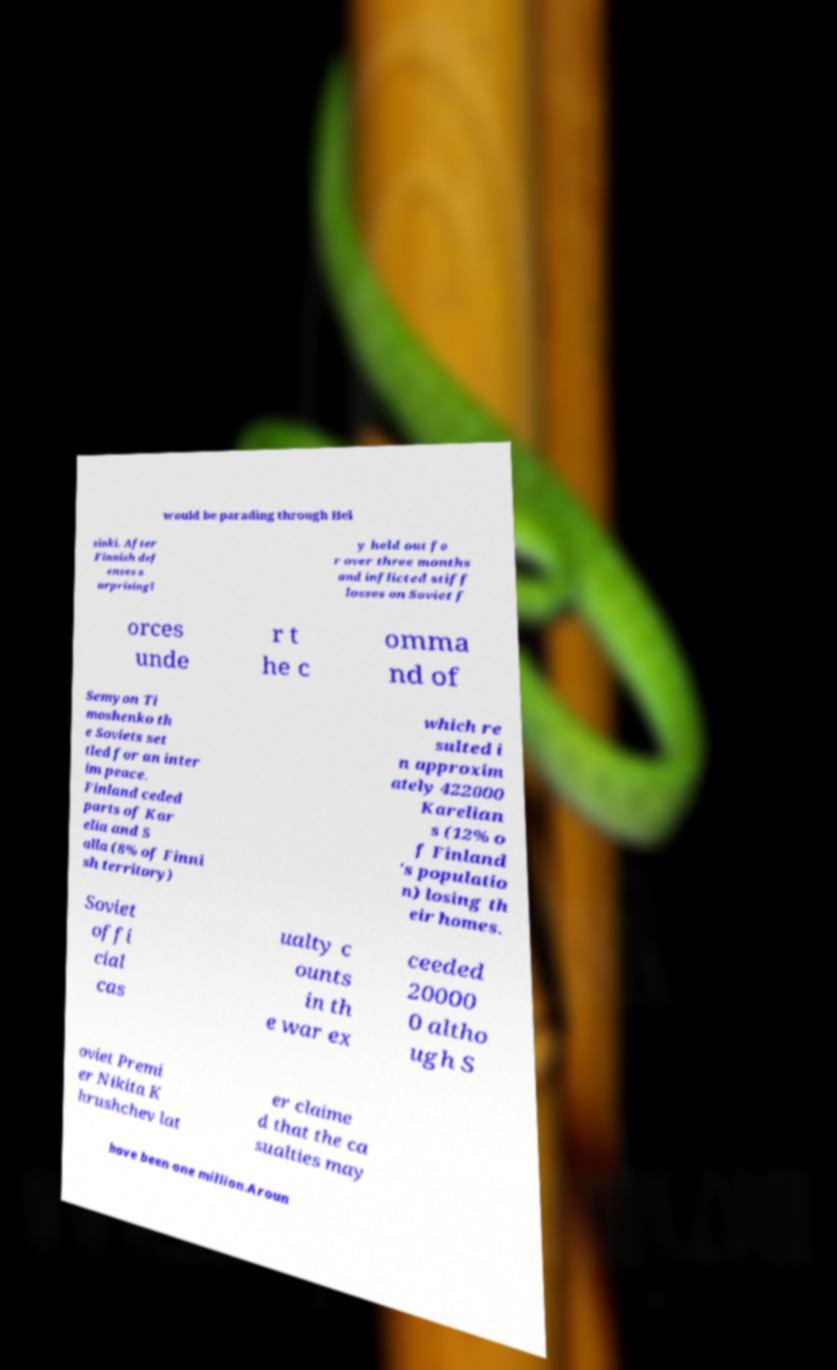Please identify and transcribe the text found in this image. would be parading through Hel sinki. After Finnish def enses s urprisingl y held out fo r over three months and inflicted stiff losses on Soviet f orces unde r t he c omma nd of Semyon Ti moshenko th e Soviets set tled for an inter im peace. Finland ceded parts of Kar elia and S alla (8% of Finni sh territory) which re sulted i n approxim ately 422000 Karelian s (12% o f Finland 's populatio n) losing th eir homes. Soviet offi cial cas ualty c ounts in th e war ex ceeded 20000 0 altho ugh S oviet Premi er Nikita K hrushchev lat er claime d that the ca sualties may have been one million.Aroun 